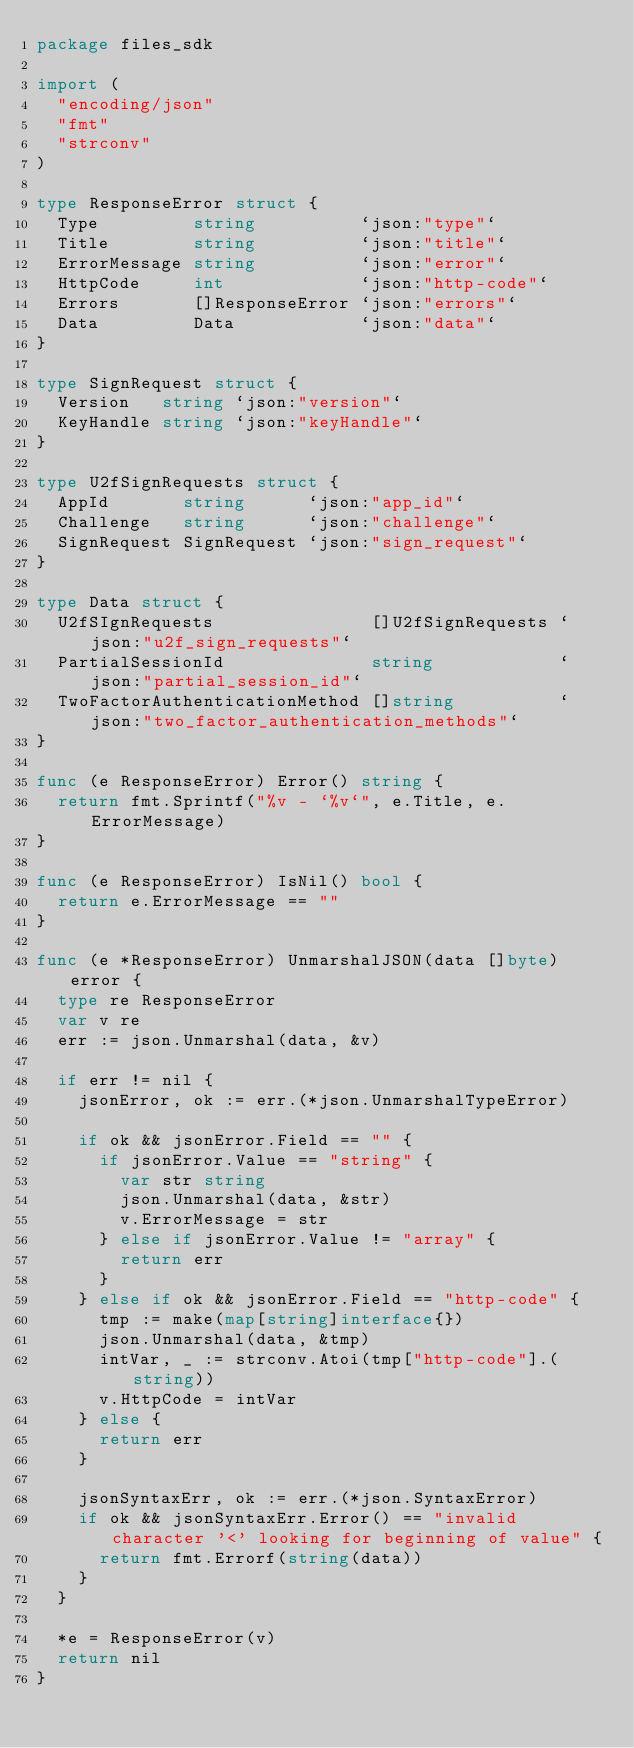<code> <loc_0><loc_0><loc_500><loc_500><_Go_>package files_sdk

import (
	"encoding/json"
	"fmt"
	"strconv"
)

type ResponseError struct {
	Type         string          `json:"type"`
	Title        string          `json:"title"`
	ErrorMessage string          `json:"error"`
	HttpCode     int             `json:"http-code"`
	Errors       []ResponseError `json:"errors"`
	Data         Data            `json:"data"`
}

type SignRequest struct {
	Version   string `json:"version"`
	KeyHandle string `json:"keyHandle"`
}

type U2fSignRequests struct {
	AppId       string      `json:"app_id"`
	Challenge   string      `json:"challenge"`
	SignRequest SignRequest `json:"sign_request"`
}

type Data struct {
	U2fSIgnRequests               []U2fSignRequests `json:"u2f_sign_requests"`
	PartialSessionId              string            `json:"partial_session_id"`
	TwoFactorAuthenticationMethod []string          `json:"two_factor_authentication_methods"`
}

func (e ResponseError) Error() string {
	return fmt.Sprintf("%v - `%v`", e.Title, e.ErrorMessage)
}

func (e ResponseError) IsNil() bool {
	return e.ErrorMessage == ""
}

func (e *ResponseError) UnmarshalJSON(data []byte) error {
	type re ResponseError
	var v re
	err := json.Unmarshal(data, &v)

	if err != nil {
		jsonError, ok := err.(*json.UnmarshalTypeError)

		if ok && jsonError.Field == "" {
			if jsonError.Value == "string" {
				var str string
				json.Unmarshal(data, &str)
				v.ErrorMessage = str
			} else if jsonError.Value != "array" {
				return err
			}
		} else if ok && jsonError.Field == "http-code" {
			tmp := make(map[string]interface{})
			json.Unmarshal(data, &tmp)
			intVar, _ := strconv.Atoi(tmp["http-code"].(string))
			v.HttpCode = intVar
		} else {
			return err
		}

		jsonSyntaxErr, ok := err.(*json.SyntaxError)
		if ok && jsonSyntaxErr.Error() == "invalid character '<' looking for beginning of value" {
			return fmt.Errorf(string(data))
		}
	}

	*e = ResponseError(v)
	return nil
}
</code> 